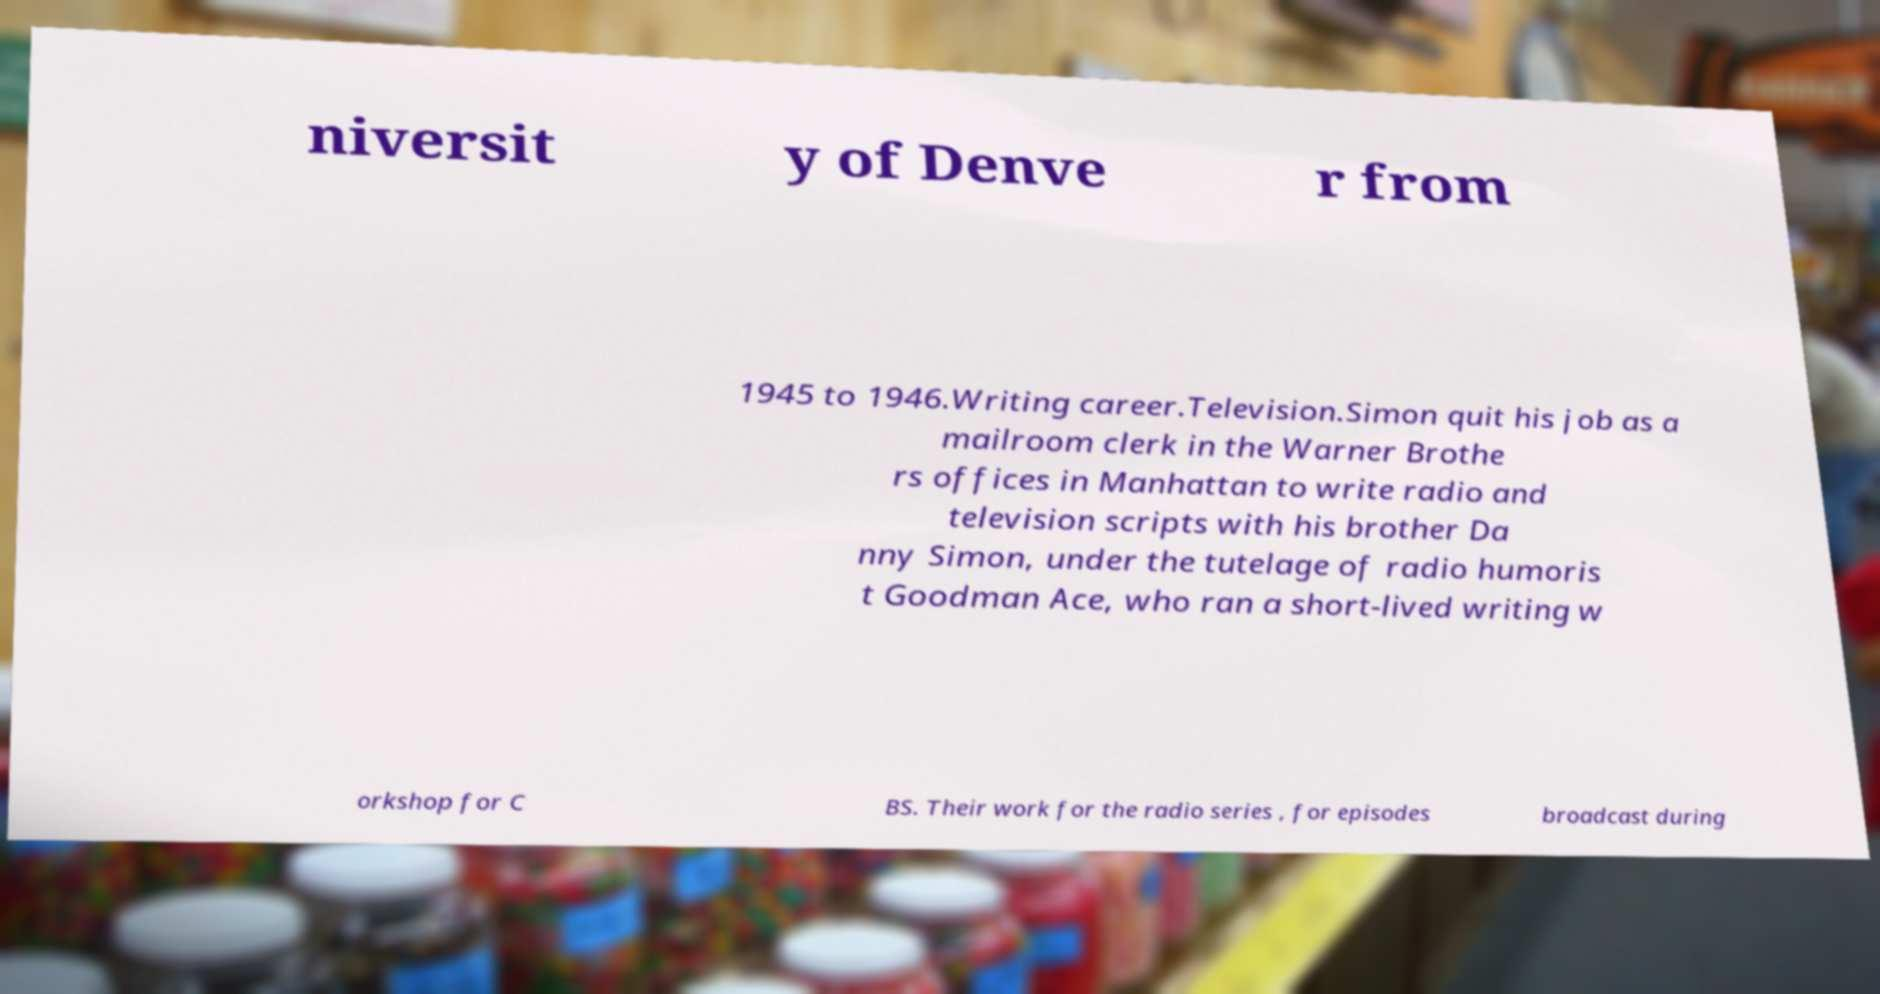Please identify and transcribe the text found in this image. niversit y of Denve r from 1945 to 1946.Writing career.Television.Simon quit his job as a mailroom clerk in the Warner Brothe rs offices in Manhattan to write radio and television scripts with his brother Da nny Simon, under the tutelage of radio humoris t Goodman Ace, who ran a short-lived writing w orkshop for C BS. Their work for the radio series , for episodes broadcast during 